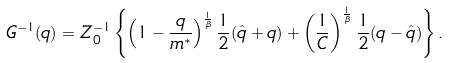<formula> <loc_0><loc_0><loc_500><loc_500>G ^ { - 1 } ( q ) = Z _ { 0 } ^ { - 1 } \left \{ \left ( 1 - \frac { q } { m ^ { * } } \right ) ^ { \frac { 1 } { \beta } } \frac { 1 } { 2 } ( \hat { q } + q ) + \left ( \frac { 1 } { C } \right ) ^ { \frac { 1 } { \beta } } \frac { 1 } { 2 } ( q - \hat { q } ) \right \} .</formula> 